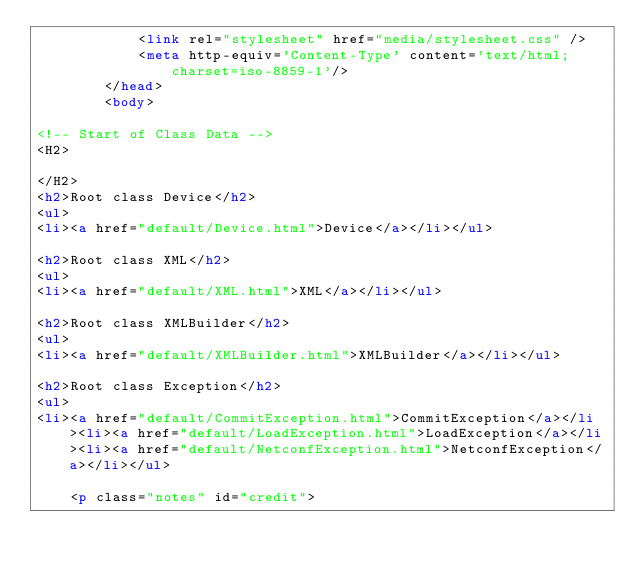Convert code to text. <code><loc_0><loc_0><loc_500><loc_500><_HTML_>			<link rel="stylesheet" href="media/stylesheet.css" />
			<meta http-equiv='Content-Type' content='text/html; charset=iso-8859-1'/>
		</head>
		<body>
						
<!-- Start of Class Data -->
<H2>
	
</H2>
<h2>Root class Device</h2>
<ul>
<li><a href="default/Device.html">Device</a></li></ul>

<h2>Root class XML</h2>
<ul>
<li><a href="default/XML.html">XML</a></li></ul>

<h2>Root class XMLBuilder</h2>
<ul>
<li><a href="default/XMLBuilder.html">XMLBuilder</a></li></ul>

<h2>Root class Exception</h2>
<ul>
<li><a href="default/CommitException.html">CommitException</a></li><li><a href="default/LoadException.html">LoadException</a></li><li><a href="default/NetconfException.html">NetconfException</a></li></ul>

	<p class="notes" id="credit"></code> 